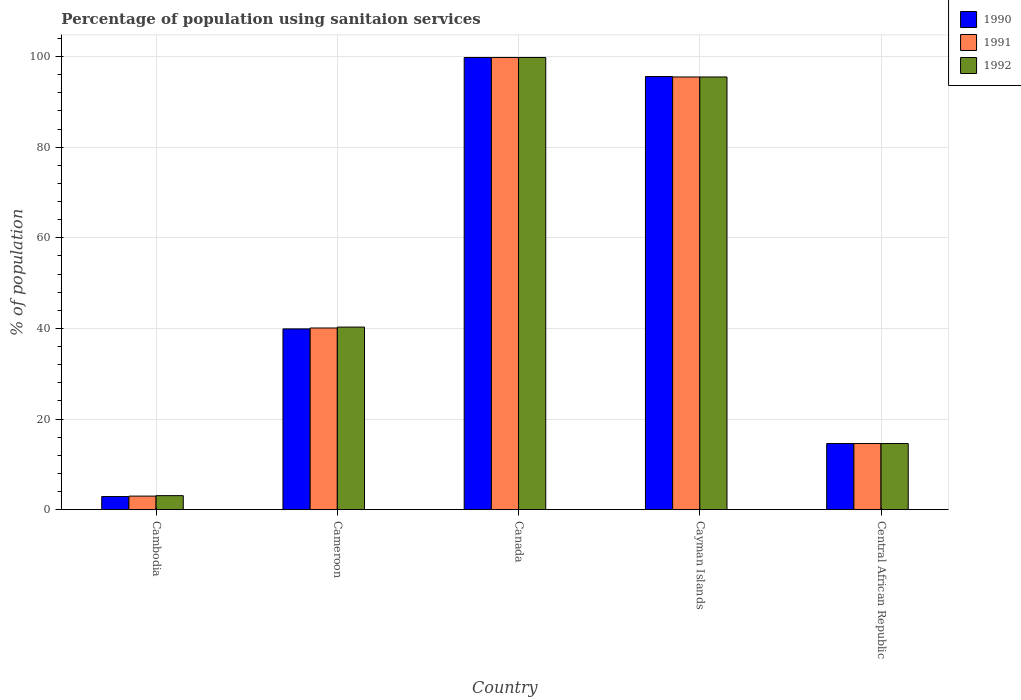How many groups of bars are there?
Your answer should be very brief. 5. Are the number of bars on each tick of the X-axis equal?
Provide a succinct answer. Yes. How many bars are there on the 2nd tick from the right?
Provide a short and direct response. 3. What is the label of the 5th group of bars from the left?
Give a very brief answer. Central African Republic. What is the percentage of population using sanitaion services in 1990 in Cambodia?
Provide a succinct answer. 2.9. Across all countries, what is the maximum percentage of population using sanitaion services in 1990?
Keep it short and to the point. 99.8. In which country was the percentage of population using sanitaion services in 1990 maximum?
Your answer should be very brief. Canada. In which country was the percentage of population using sanitaion services in 1991 minimum?
Your response must be concise. Cambodia. What is the total percentage of population using sanitaion services in 1991 in the graph?
Offer a terse response. 253. What is the difference between the percentage of population using sanitaion services in 1990 in Cambodia and that in Canada?
Ensure brevity in your answer.  -96.9. What is the difference between the percentage of population using sanitaion services in 1992 in Central African Republic and the percentage of population using sanitaion services in 1991 in Cameroon?
Provide a short and direct response. -25.5. What is the average percentage of population using sanitaion services in 1990 per country?
Keep it short and to the point. 50.56. What is the difference between the percentage of population using sanitaion services of/in 1991 and percentage of population using sanitaion services of/in 1990 in Cayman Islands?
Your response must be concise. -0.1. In how many countries, is the percentage of population using sanitaion services in 1990 greater than 12 %?
Ensure brevity in your answer.  4. What is the ratio of the percentage of population using sanitaion services in 1992 in Cambodia to that in Cameroon?
Your answer should be compact. 0.08. Is the difference between the percentage of population using sanitaion services in 1991 in Cameroon and Central African Republic greater than the difference between the percentage of population using sanitaion services in 1990 in Cameroon and Central African Republic?
Offer a terse response. Yes. What is the difference between the highest and the second highest percentage of population using sanitaion services in 1991?
Make the answer very short. -59.7. What is the difference between the highest and the lowest percentage of population using sanitaion services in 1991?
Offer a very short reply. 96.8. What does the 2nd bar from the right in Canada represents?
Provide a succinct answer. 1991. How many bars are there?
Make the answer very short. 15. Are all the bars in the graph horizontal?
Your answer should be compact. No. What is the difference between two consecutive major ticks on the Y-axis?
Offer a very short reply. 20. Are the values on the major ticks of Y-axis written in scientific E-notation?
Offer a terse response. No. What is the title of the graph?
Give a very brief answer. Percentage of population using sanitaion services. Does "1978" appear as one of the legend labels in the graph?
Offer a terse response. No. What is the label or title of the X-axis?
Make the answer very short. Country. What is the label or title of the Y-axis?
Make the answer very short. % of population. What is the % of population in 1992 in Cambodia?
Offer a very short reply. 3.1. What is the % of population of 1990 in Cameroon?
Give a very brief answer. 39.9. What is the % of population of 1991 in Cameroon?
Your response must be concise. 40.1. What is the % of population of 1992 in Cameroon?
Keep it short and to the point. 40.3. What is the % of population of 1990 in Canada?
Your answer should be very brief. 99.8. What is the % of population in 1991 in Canada?
Your response must be concise. 99.8. What is the % of population in 1992 in Canada?
Your answer should be very brief. 99.8. What is the % of population in 1990 in Cayman Islands?
Provide a short and direct response. 95.6. What is the % of population in 1991 in Cayman Islands?
Provide a succinct answer. 95.5. What is the % of population in 1992 in Cayman Islands?
Offer a very short reply. 95.5. What is the % of population of 1990 in Central African Republic?
Provide a short and direct response. 14.6. What is the % of population of 1991 in Central African Republic?
Provide a short and direct response. 14.6. What is the % of population in 1992 in Central African Republic?
Your response must be concise. 14.6. Across all countries, what is the maximum % of population of 1990?
Provide a succinct answer. 99.8. Across all countries, what is the maximum % of population in 1991?
Your response must be concise. 99.8. Across all countries, what is the maximum % of population in 1992?
Provide a short and direct response. 99.8. Across all countries, what is the minimum % of population of 1991?
Your response must be concise. 3. Across all countries, what is the minimum % of population in 1992?
Your answer should be compact. 3.1. What is the total % of population in 1990 in the graph?
Give a very brief answer. 252.8. What is the total % of population of 1991 in the graph?
Ensure brevity in your answer.  253. What is the total % of population of 1992 in the graph?
Your response must be concise. 253.3. What is the difference between the % of population of 1990 in Cambodia and that in Cameroon?
Provide a short and direct response. -37. What is the difference between the % of population in 1991 in Cambodia and that in Cameroon?
Offer a very short reply. -37.1. What is the difference between the % of population of 1992 in Cambodia and that in Cameroon?
Offer a very short reply. -37.2. What is the difference between the % of population of 1990 in Cambodia and that in Canada?
Your answer should be very brief. -96.9. What is the difference between the % of population of 1991 in Cambodia and that in Canada?
Provide a succinct answer. -96.8. What is the difference between the % of population of 1992 in Cambodia and that in Canada?
Make the answer very short. -96.7. What is the difference between the % of population in 1990 in Cambodia and that in Cayman Islands?
Your answer should be compact. -92.7. What is the difference between the % of population of 1991 in Cambodia and that in Cayman Islands?
Your answer should be very brief. -92.5. What is the difference between the % of population in 1992 in Cambodia and that in Cayman Islands?
Provide a succinct answer. -92.4. What is the difference between the % of population in 1990 in Cambodia and that in Central African Republic?
Make the answer very short. -11.7. What is the difference between the % of population of 1992 in Cambodia and that in Central African Republic?
Keep it short and to the point. -11.5. What is the difference between the % of population in 1990 in Cameroon and that in Canada?
Your response must be concise. -59.9. What is the difference between the % of population in 1991 in Cameroon and that in Canada?
Provide a short and direct response. -59.7. What is the difference between the % of population in 1992 in Cameroon and that in Canada?
Make the answer very short. -59.5. What is the difference between the % of population of 1990 in Cameroon and that in Cayman Islands?
Ensure brevity in your answer.  -55.7. What is the difference between the % of population of 1991 in Cameroon and that in Cayman Islands?
Your answer should be very brief. -55.4. What is the difference between the % of population of 1992 in Cameroon and that in Cayman Islands?
Make the answer very short. -55.2. What is the difference between the % of population of 1990 in Cameroon and that in Central African Republic?
Make the answer very short. 25.3. What is the difference between the % of population of 1991 in Cameroon and that in Central African Republic?
Ensure brevity in your answer.  25.5. What is the difference between the % of population of 1992 in Cameroon and that in Central African Republic?
Make the answer very short. 25.7. What is the difference between the % of population of 1990 in Canada and that in Cayman Islands?
Offer a terse response. 4.2. What is the difference between the % of population of 1991 in Canada and that in Cayman Islands?
Give a very brief answer. 4.3. What is the difference between the % of population of 1990 in Canada and that in Central African Republic?
Give a very brief answer. 85.2. What is the difference between the % of population in 1991 in Canada and that in Central African Republic?
Make the answer very short. 85.2. What is the difference between the % of population of 1992 in Canada and that in Central African Republic?
Provide a short and direct response. 85.2. What is the difference between the % of population in 1990 in Cayman Islands and that in Central African Republic?
Give a very brief answer. 81. What is the difference between the % of population of 1991 in Cayman Islands and that in Central African Republic?
Your answer should be very brief. 80.9. What is the difference between the % of population of 1992 in Cayman Islands and that in Central African Republic?
Your answer should be very brief. 80.9. What is the difference between the % of population of 1990 in Cambodia and the % of population of 1991 in Cameroon?
Give a very brief answer. -37.2. What is the difference between the % of population of 1990 in Cambodia and the % of population of 1992 in Cameroon?
Provide a short and direct response. -37.4. What is the difference between the % of population of 1991 in Cambodia and the % of population of 1992 in Cameroon?
Ensure brevity in your answer.  -37.3. What is the difference between the % of population of 1990 in Cambodia and the % of population of 1991 in Canada?
Your answer should be compact. -96.9. What is the difference between the % of population of 1990 in Cambodia and the % of population of 1992 in Canada?
Offer a terse response. -96.9. What is the difference between the % of population of 1991 in Cambodia and the % of population of 1992 in Canada?
Provide a short and direct response. -96.8. What is the difference between the % of population in 1990 in Cambodia and the % of population in 1991 in Cayman Islands?
Your answer should be compact. -92.6. What is the difference between the % of population of 1990 in Cambodia and the % of population of 1992 in Cayman Islands?
Ensure brevity in your answer.  -92.6. What is the difference between the % of population of 1991 in Cambodia and the % of population of 1992 in Cayman Islands?
Ensure brevity in your answer.  -92.5. What is the difference between the % of population in 1990 in Cambodia and the % of population in 1992 in Central African Republic?
Provide a succinct answer. -11.7. What is the difference between the % of population of 1991 in Cambodia and the % of population of 1992 in Central African Republic?
Your answer should be compact. -11.6. What is the difference between the % of population of 1990 in Cameroon and the % of population of 1991 in Canada?
Offer a very short reply. -59.9. What is the difference between the % of population in 1990 in Cameroon and the % of population in 1992 in Canada?
Offer a terse response. -59.9. What is the difference between the % of population of 1991 in Cameroon and the % of population of 1992 in Canada?
Provide a short and direct response. -59.7. What is the difference between the % of population of 1990 in Cameroon and the % of population of 1991 in Cayman Islands?
Ensure brevity in your answer.  -55.6. What is the difference between the % of population of 1990 in Cameroon and the % of population of 1992 in Cayman Islands?
Keep it short and to the point. -55.6. What is the difference between the % of population of 1991 in Cameroon and the % of population of 1992 in Cayman Islands?
Keep it short and to the point. -55.4. What is the difference between the % of population of 1990 in Cameroon and the % of population of 1991 in Central African Republic?
Ensure brevity in your answer.  25.3. What is the difference between the % of population of 1990 in Cameroon and the % of population of 1992 in Central African Republic?
Your answer should be very brief. 25.3. What is the difference between the % of population in 1990 in Canada and the % of population in 1991 in Central African Republic?
Ensure brevity in your answer.  85.2. What is the difference between the % of population of 1990 in Canada and the % of population of 1992 in Central African Republic?
Ensure brevity in your answer.  85.2. What is the difference between the % of population of 1991 in Canada and the % of population of 1992 in Central African Republic?
Make the answer very short. 85.2. What is the difference between the % of population of 1990 in Cayman Islands and the % of population of 1991 in Central African Republic?
Provide a succinct answer. 81. What is the difference between the % of population of 1991 in Cayman Islands and the % of population of 1992 in Central African Republic?
Your response must be concise. 80.9. What is the average % of population in 1990 per country?
Offer a very short reply. 50.56. What is the average % of population of 1991 per country?
Your answer should be very brief. 50.6. What is the average % of population in 1992 per country?
Provide a short and direct response. 50.66. What is the difference between the % of population in 1990 and % of population in 1991 in Cambodia?
Keep it short and to the point. -0.1. What is the difference between the % of population of 1990 and % of population of 1992 in Cambodia?
Your answer should be compact. -0.2. What is the difference between the % of population in 1991 and % of population in 1992 in Cambodia?
Give a very brief answer. -0.1. What is the difference between the % of population in 1990 and % of population in 1991 in Cameroon?
Keep it short and to the point. -0.2. What is the difference between the % of population of 1990 and % of population of 1992 in Cameroon?
Offer a very short reply. -0.4. What is the difference between the % of population of 1991 and % of population of 1992 in Cameroon?
Offer a terse response. -0.2. What is the difference between the % of population of 1990 and % of population of 1992 in Canada?
Ensure brevity in your answer.  0. What is the difference between the % of population of 1991 and % of population of 1992 in Canada?
Keep it short and to the point. 0. What is the difference between the % of population of 1990 and % of population of 1991 in Cayman Islands?
Provide a succinct answer. 0.1. What is the difference between the % of population of 1991 and % of population of 1992 in Cayman Islands?
Keep it short and to the point. 0. What is the difference between the % of population of 1990 and % of population of 1991 in Central African Republic?
Keep it short and to the point. 0. What is the difference between the % of population in 1991 and % of population in 1992 in Central African Republic?
Make the answer very short. 0. What is the ratio of the % of population in 1990 in Cambodia to that in Cameroon?
Ensure brevity in your answer.  0.07. What is the ratio of the % of population of 1991 in Cambodia to that in Cameroon?
Ensure brevity in your answer.  0.07. What is the ratio of the % of population of 1992 in Cambodia to that in Cameroon?
Keep it short and to the point. 0.08. What is the ratio of the % of population in 1990 in Cambodia to that in Canada?
Your answer should be very brief. 0.03. What is the ratio of the % of population in 1991 in Cambodia to that in Canada?
Provide a short and direct response. 0.03. What is the ratio of the % of population of 1992 in Cambodia to that in Canada?
Offer a very short reply. 0.03. What is the ratio of the % of population of 1990 in Cambodia to that in Cayman Islands?
Offer a terse response. 0.03. What is the ratio of the % of population in 1991 in Cambodia to that in Cayman Islands?
Give a very brief answer. 0.03. What is the ratio of the % of population in 1992 in Cambodia to that in Cayman Islands?
Offer a very short reply. 0.03. What is the ratio of the % of population in 1990 in Cambodia to that in Central African Republic?
Your answer should be very brief. 0.2. What is the ratio of the % of population of 1991 in Cambodia to that in Central African Republic?
Your answer should be very brief. 0.21. What is the ratio of the % of population of 1992 in Cambodia to that in Central African Republic?
Provide a short and direct response. 0.21. What is the ratio of the % of population in 1990 in Cameroon to that in Canada?
Your response must be concise. 0.4. What is the ratio of the % of population in 1991 in Cameroon to that in Canada?
Ensure brevity in your answer.  0.4. What is the ratio of the % of population of 1992 in Cameroon to that in Canada?
Make the answer very short. 0.4. What is the ratio of the % of population in 1990 in Cameroon to that in Cayman Islands?
Give a very brief answer. 0.42. What is the ratio of the % of population in 1991 in Cameroon to that in Cayman Islands?
Keep it short and to the point. 0.42. What is the ratio of the % of population in 1992 in Cameroon to that in Cayman Islands?
Ensure brevity in your answer.  0.42. What is the ratio of the % of population in 1990 in Cameroon to that in Central African Republic?
Offer a very short reply. 2.73. What is the ratio of the % of population of 1991 in Cameroon to that in Central African Republic?
Give a very brief answer. 2.75. What is the ratio of the % of population of 1992 in Cameroon to that in Central African Republic?
Your answer should be very brief. 2.76. What is the ratio of the % of population in 1990 in Canada to that in Cayman Islands?
Offer a terse response. 1.04. What is the ratio of the % of population of 1991 in Canada to that in Cayman Islands?
Keep it short and to the point. 1.04. What is the ratio of the % of population of 1992 in Canada to that in Cayman Islands?
Your answer should be very brief. 1.04. What is the ratio of the % of population in 1990 in Canada to that in Central African Republic?
Give a very brief answer. 6.84. What is the ratio of the % of population in 1991 in Canada to that in Central African Republic?
Offer a very short reply. 6.84. What is the ratio of the % of population of 1992 in Canada to that in Central African Republic?
Your response must be concise. 6.84. What is the ratio of the % of population in 1990 in Cayman Islands to that in Central African Republic?
Your response must be concise. 6.55. What is the ratio of the % of population in 1991 in Cayman Islands to that in Central African Republic?
Offer a terse response. 6.54. What is the ratio of the % of population in 1992 in Cayman Islands to that in Central African Republic?
Provide a succinct answer. 6.54. What is the difference between the highest and the second highest % of population in 1990?
Your answer should be compact. 4.2. What is the difference between the highest and the second highest % of population of 1992?
Offer a terse response. 4.3. What is the difference between the highest and the lowest % of population of 1990?
Offer a very short reply. 96.9. What is the difference between the highest and the lowest % of population of 1991?
Give a very brief answer. 96.8. What is the difference between the highest and the lowest % of population of 1992?
Provide a succinct answer. 96.7. 